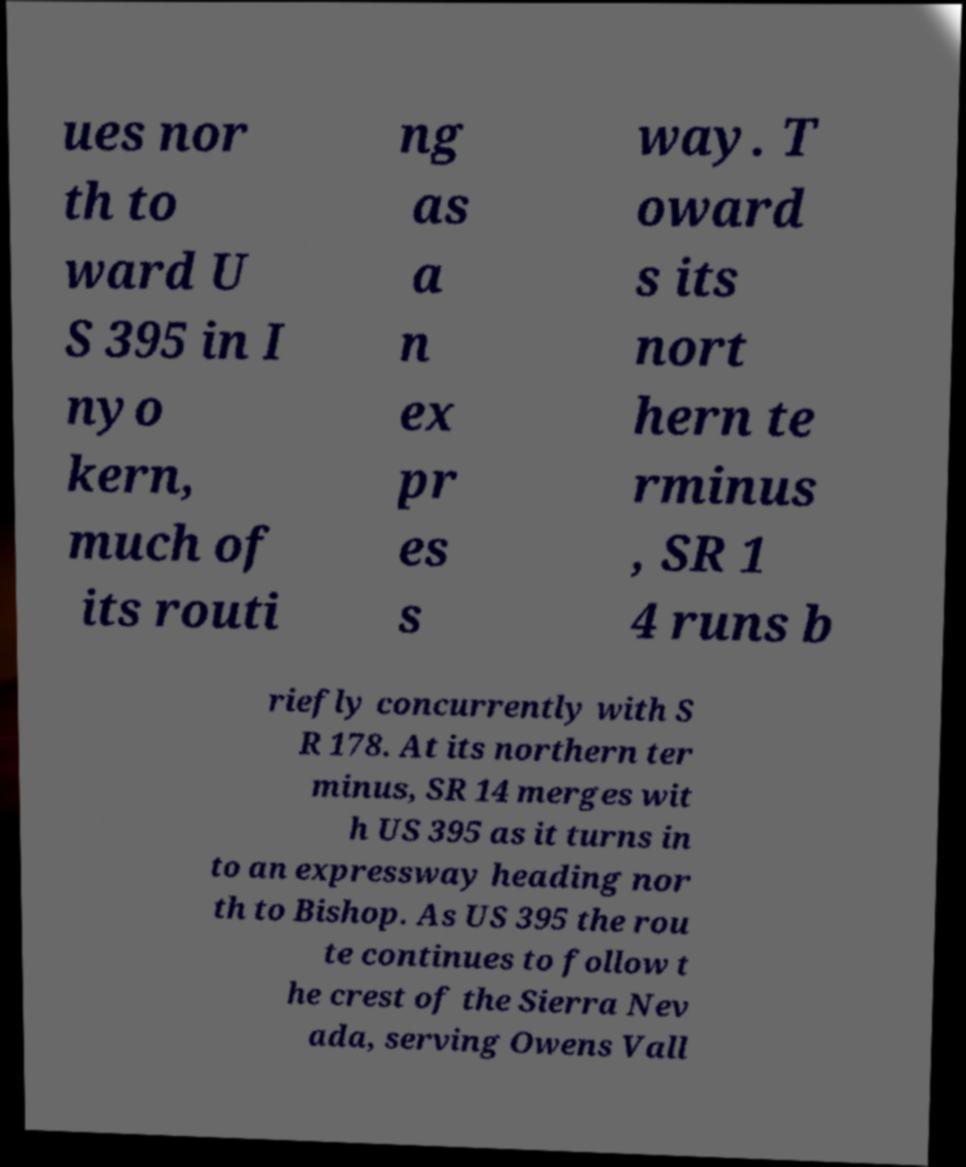For documentation purposes, I need the text within this image transcribed. Could you provide that? ues nor th to ward U S 395 in I nyo kern, much of its routi ng as a n ex pr es s way. T oward s its nort hern te rminus , SR 1 4 runs b riefly concurrently with S R 178. At its northern ter minus, SR 14 merges wit h US 395 as it turns in to an expressway heading nor th to Bishop. As US 395 the rou te continues to follow t he crest of the Sierra Nev ada, serving Owens Vall 